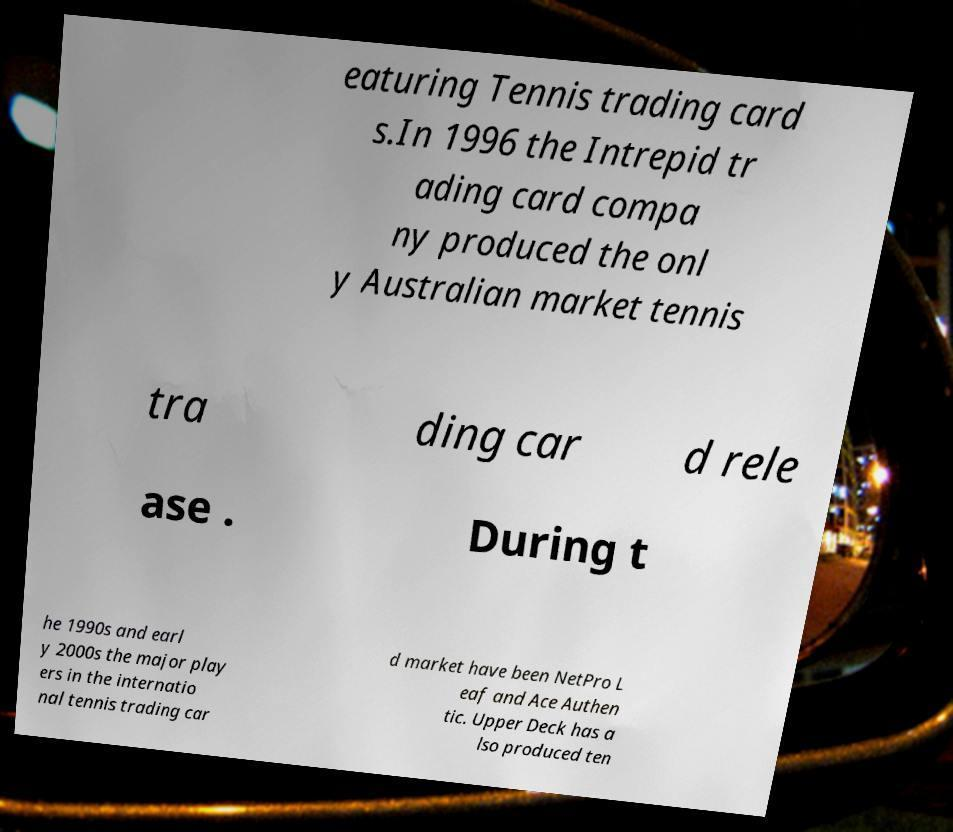What messages or text are displayed in this image? I need them in a readable, typed format. eaturing Tennis trading card s.In 1996 the Intrepid tr ading card compa ny produced the onl y Australian market tennis tra ding car d rele ase . During t he 1990s and earl y 2000s the major play ers in the internatio nal tennis trading car d market have been NetPro L eaf and Ace Authen tic. Upper Deck has a lso produced ten 